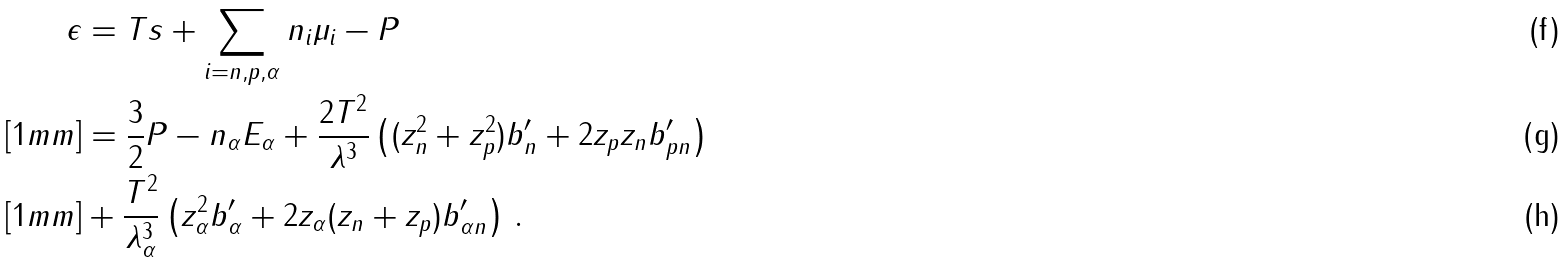<formula> <loc_0><loc_0><loc_500><loc_500>\epsilon & = T s + \sum _ { i = n , p , \alpha } n _ { i } \mu _ { i } - P \\ [ 1 m m ] & = \frac { 3 } { 2 } P - n _ { \alpha } E _ { \alpha } + \frac { 2 T ^ { 2 } } { \lambda ^ { 3 } } \left ( ( z _ { n } ^ { 2 } + z _ { p } ^ { 2 } ) b _ { n } ^ { \prime } + 2 z _ { p } z _ { n } b _ { p n } ^ { \prime } \right ) \\ [ 1 m m ] & + \frac { T ^ { 2 } } { \lambda _ { \alpha } ^ { 3 } } \left ( z _ { \alpha } ^ { 2 } b _ { \alpha } ^ { \prime } + 2 z _ { \alpha } ( z _ { n } + z _ { p } ) b _ { \alpha n } ^ { \prime } \right ) \, .</formula> 